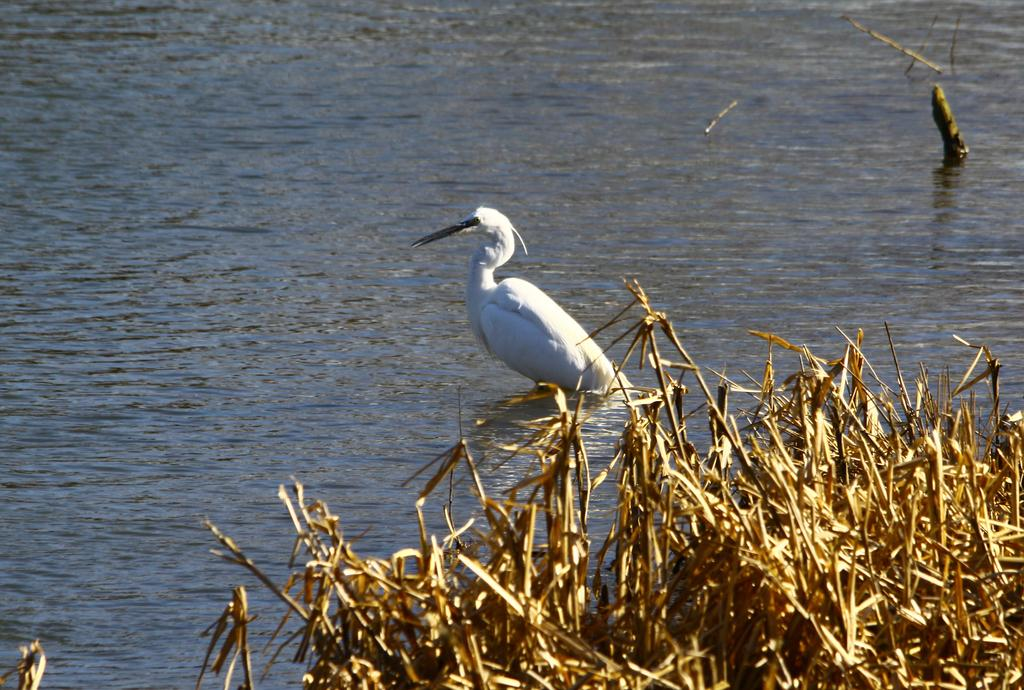What is the setting of the image? The image has an outside view. What can be seen on the water in the image? There is a crane on the water. What type of vegetation is present at the bottom right of the image? There is grass on the bottom right of the image. What type of insurance is required for the crane in the image? There is no information about insurance in the image, as it focuses on the crane's presence on the water and the surrounding grass. 